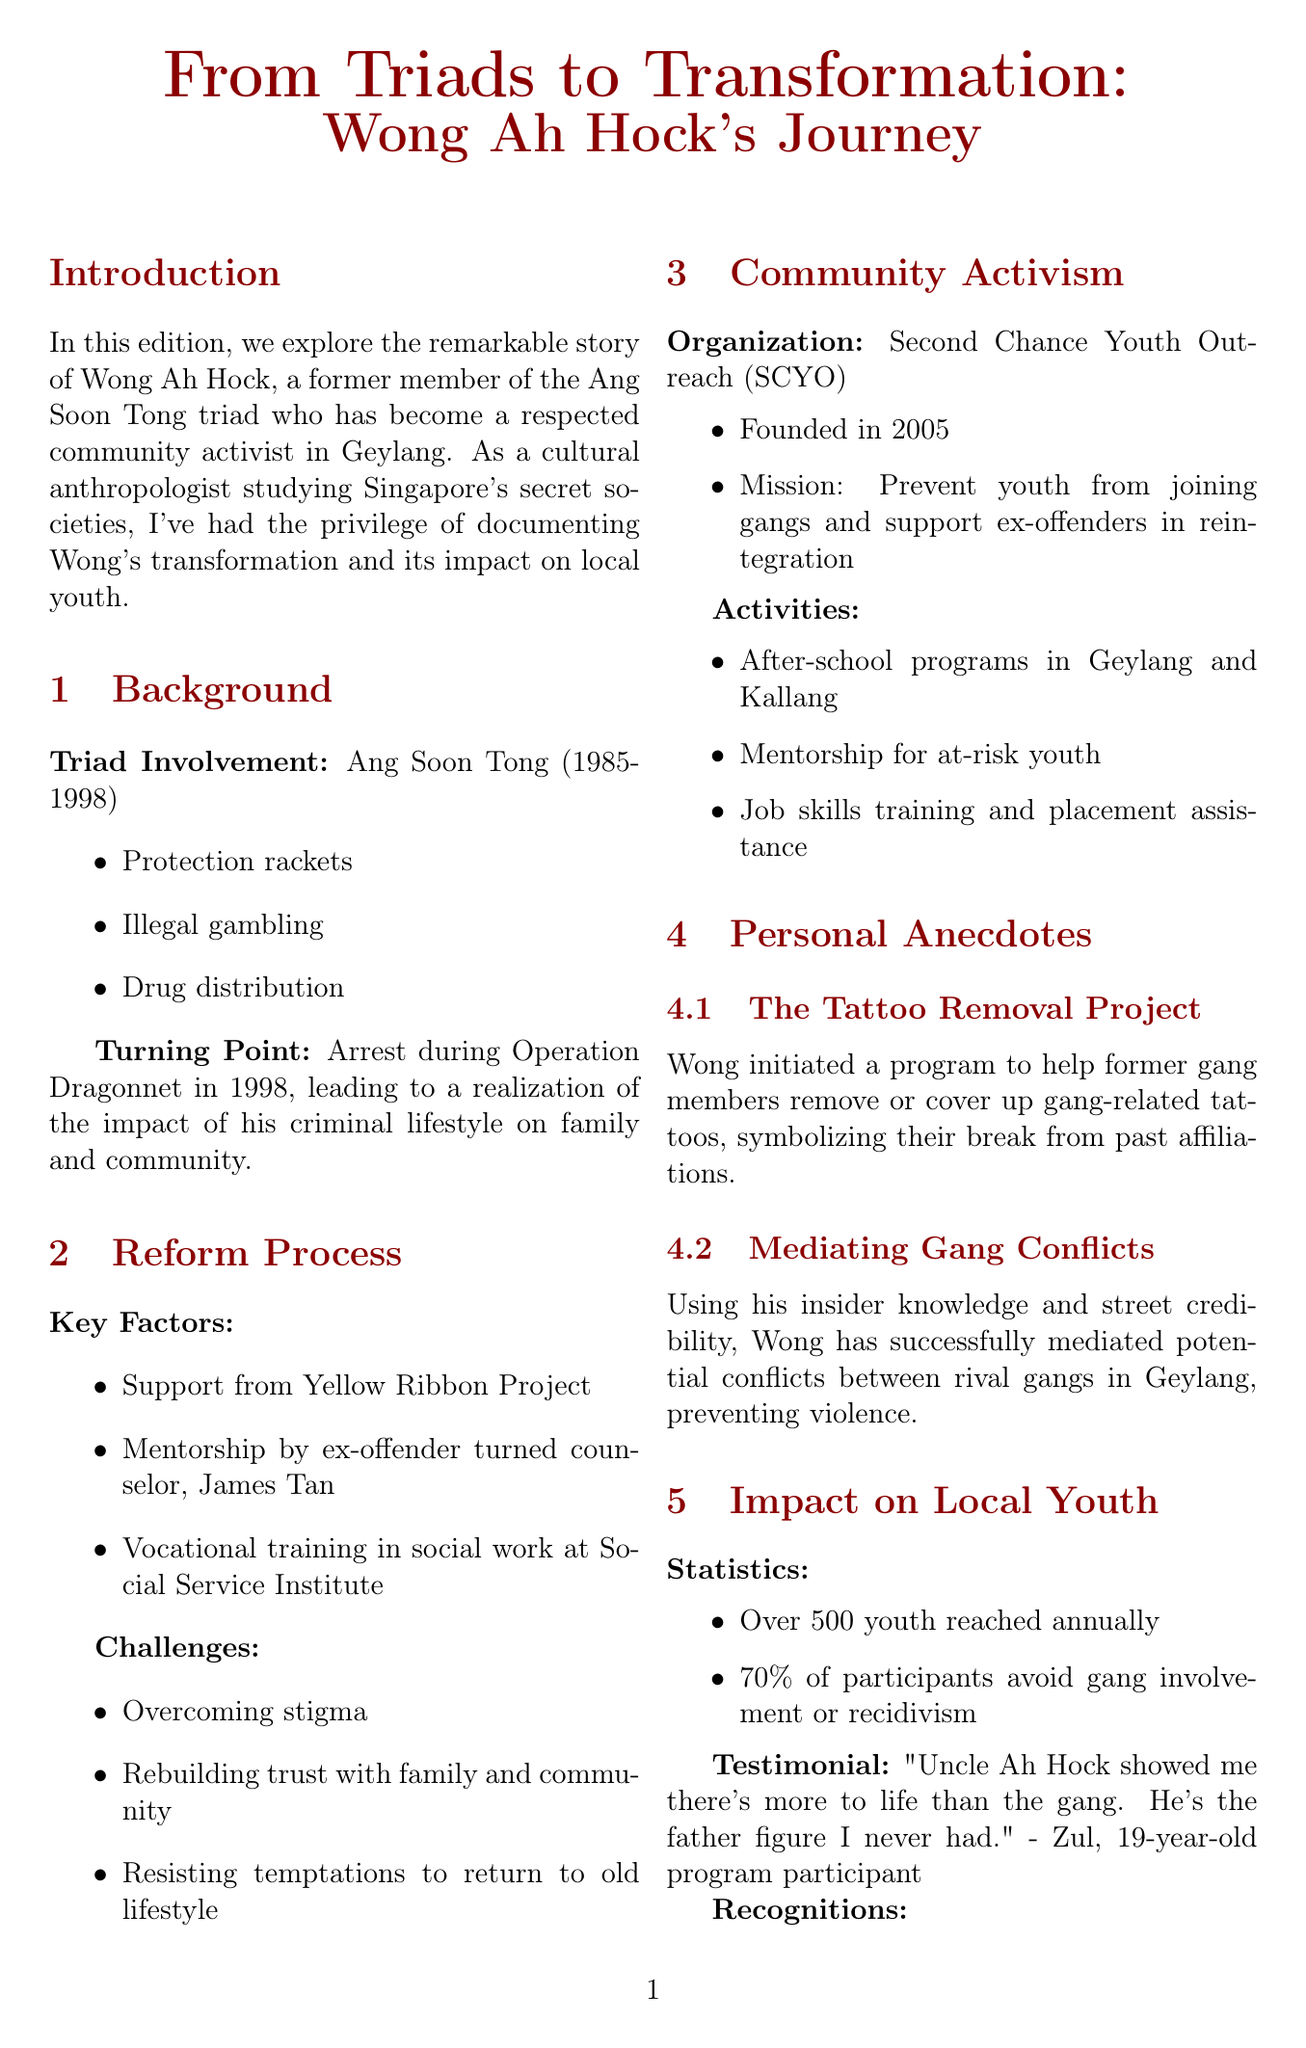What was Wong Ah Hock's involvement in the triad? Wong Ah Hock was a member of the Ang Soon Tong triad from 1985 to 1998, involved in protection rackets, illegal gambling, and drug distribution.
Answer: Ang Soon Tong What year did Wong experience a turning point in his life? Wong's turning point occurred in 1998 when he was arrested during Operation Dragonnet.
Answer: 1998 How many youth does SCYO reach annually? The document states that SCYO reaches over 500 youth each year.
Answer: Over 500 What is the success rate of SCYO participants in avoiding gang involvement? According to the document, 70% of participants avoid gang involvement or recidivism.
Answer: 70% Who mentored Wong during his reform process? The document mentions that James Tan, an ex-offender turned counselor, mentored Wong.
Answer: James Tan What was the mission of the Second Chance Youth Outreach? The mission of SCYO is to prevent youth from joining gangs and support ex-offenders in reintegration.
Answer: Prevent youth from joining gangs What community initiative did Wong start to help former gang members? Wong initiated the Tattoo Removal Project to assist former gang members with gang-related tattoos.
Answer: The Tattoo Removal Project Which award did Wong receive in 2020? Wong received the President's Volunteerism & Philanthropy Award in 2020.
Answer: President's Volunteerism & Philanthropy Award 2020 How many years did Wong participate in illegal activities before his arrest? Wong was involved from 1985 to 1998, which totals 13 years of criminal activities.
Answer: 13 years 